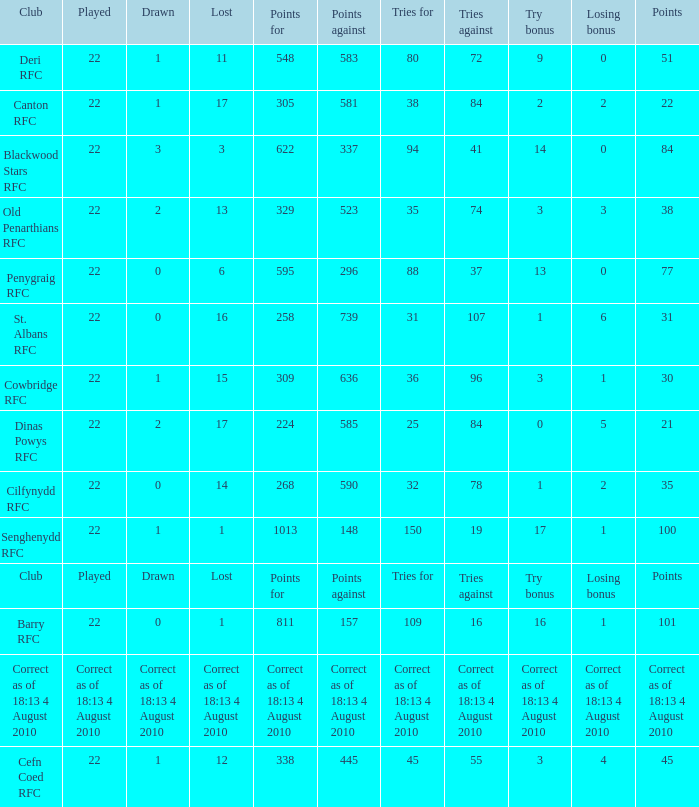What is the played number when tries against is 84, and drawn is 2? 22.0. 